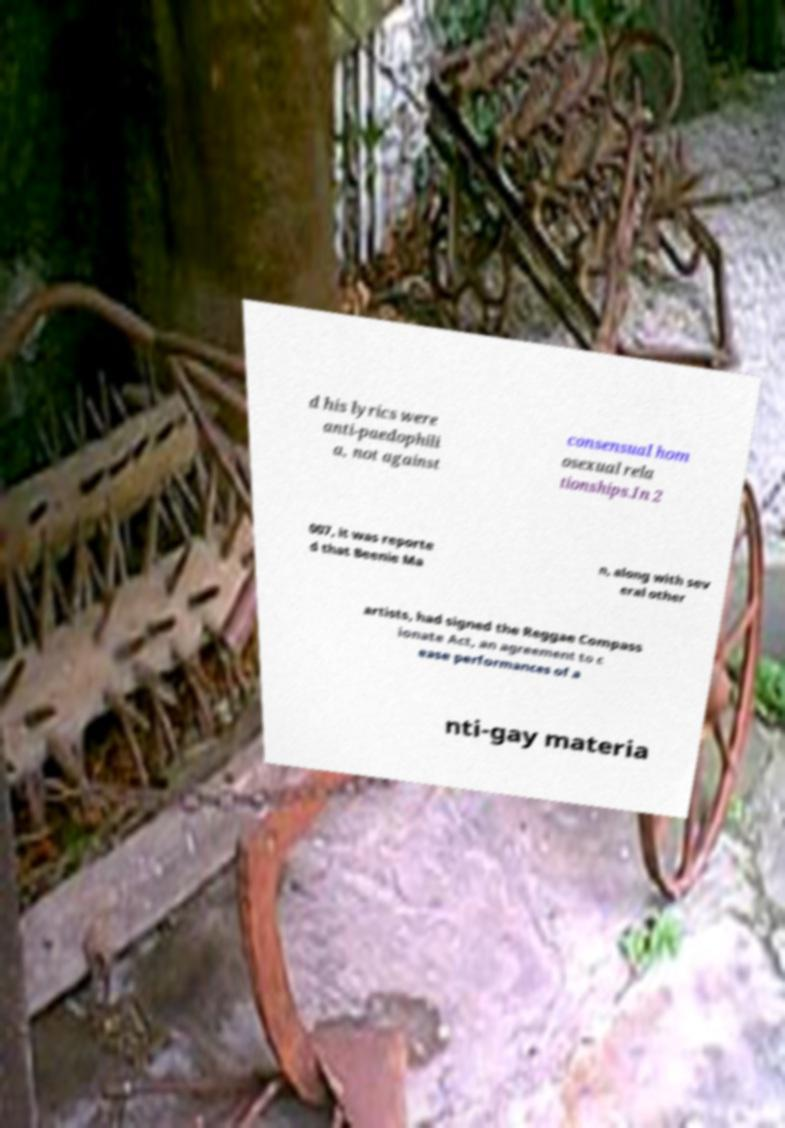There's text embedded in this image that I need extracted. Can you transcribe it verbatim? d his lyrics were anti-paedophili a, not against consensual hom osexual rela tionships.In 2 007, it was reporte d that Beenie Ma n, along with sev eral other artists, had signed the Reggae Compass ionate Act, an agreement to c ease performances of a nti-gay materia 